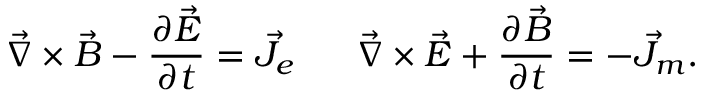<formula> <loc_0><loc_0><loc_500><loc_500>\vec { \nabla } \times \vec { B } - { \frac { \partial \vec { E } } { \partial t } } = \vec { J } _ { e } \vec { \nabla } \times \vec { E } + { \frac { \partial \vec { B } } { \partial t } } = - \vec { J } _ { m } .</formula> 